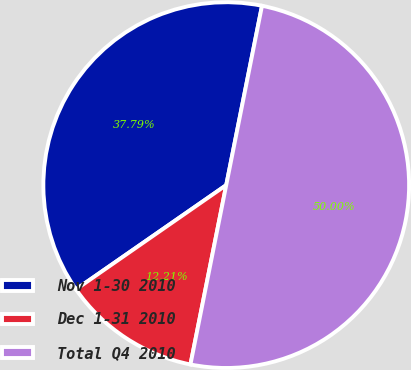<chart> <loc_0><loc_0><loc_500><loc_500><pie_chart><fcel>Nov 1-30 2010<fcel>Dec 1-31 2010<fcel>Total Q4 2010<nl><fcel>37.79%<fcel>12.21%<fcel>50.0%<nl></chart> 